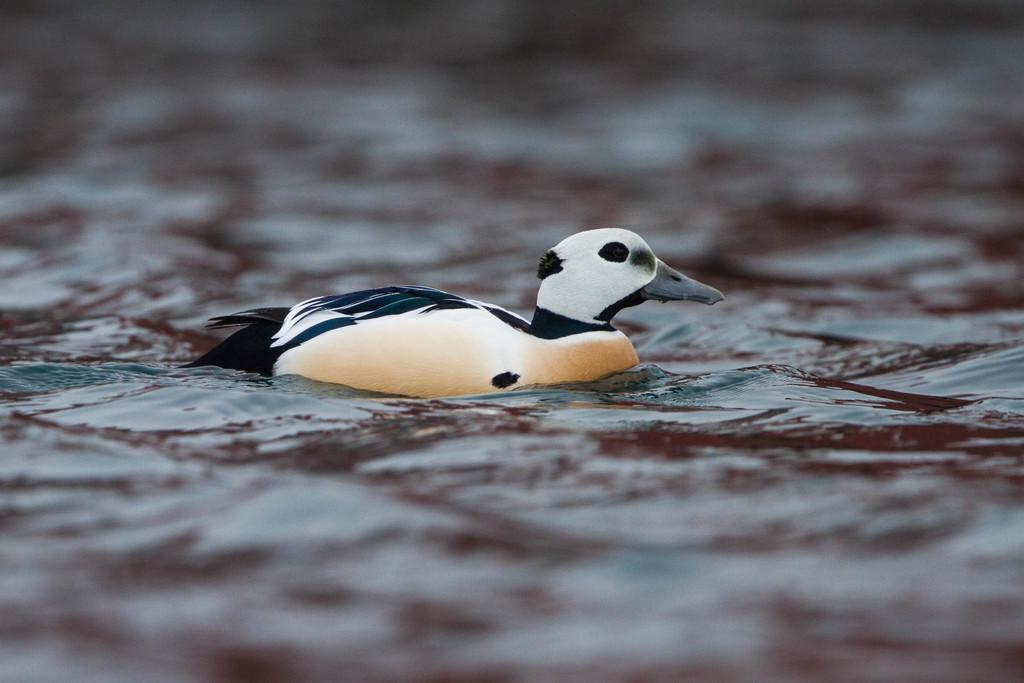What type of animal can be seen in the water in the image? There is a bird in the water in the image. Can you describe the background of the image? The background of the image is blurred. How many oranges are visible on the sweater in the bedroom in the image? There are no oranges, sweaters, or bedrooms present in the image; it features a bird in the water with a blurred background. 